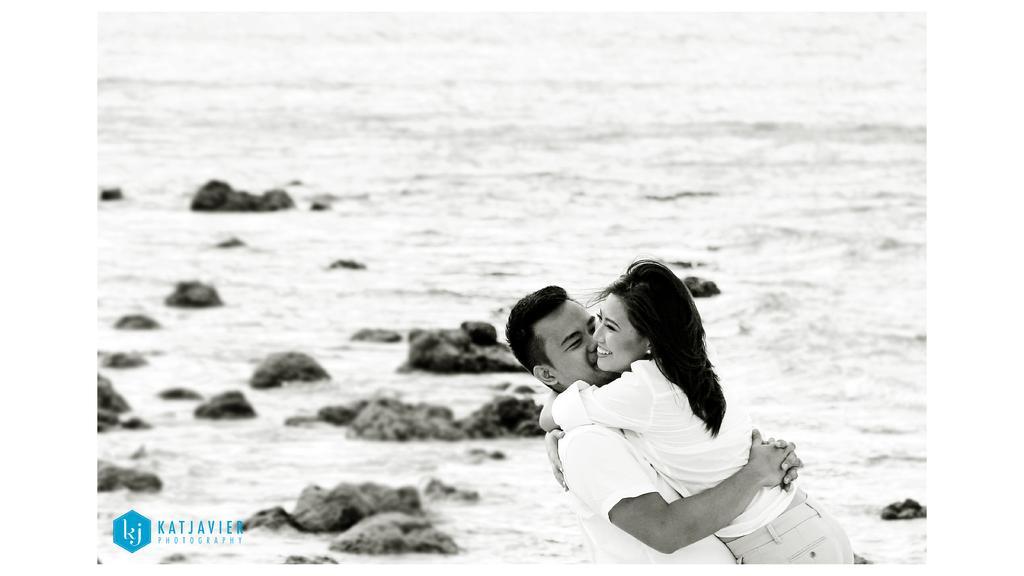Describe this image in one or two sentences. In front of the picture, we see the man and the woman in white dresses are hugging each other and both of them are smiling. At the bottom, we see the stones or rocks. In the background, we see water and this water might be in the sea. This might be an edited image. 